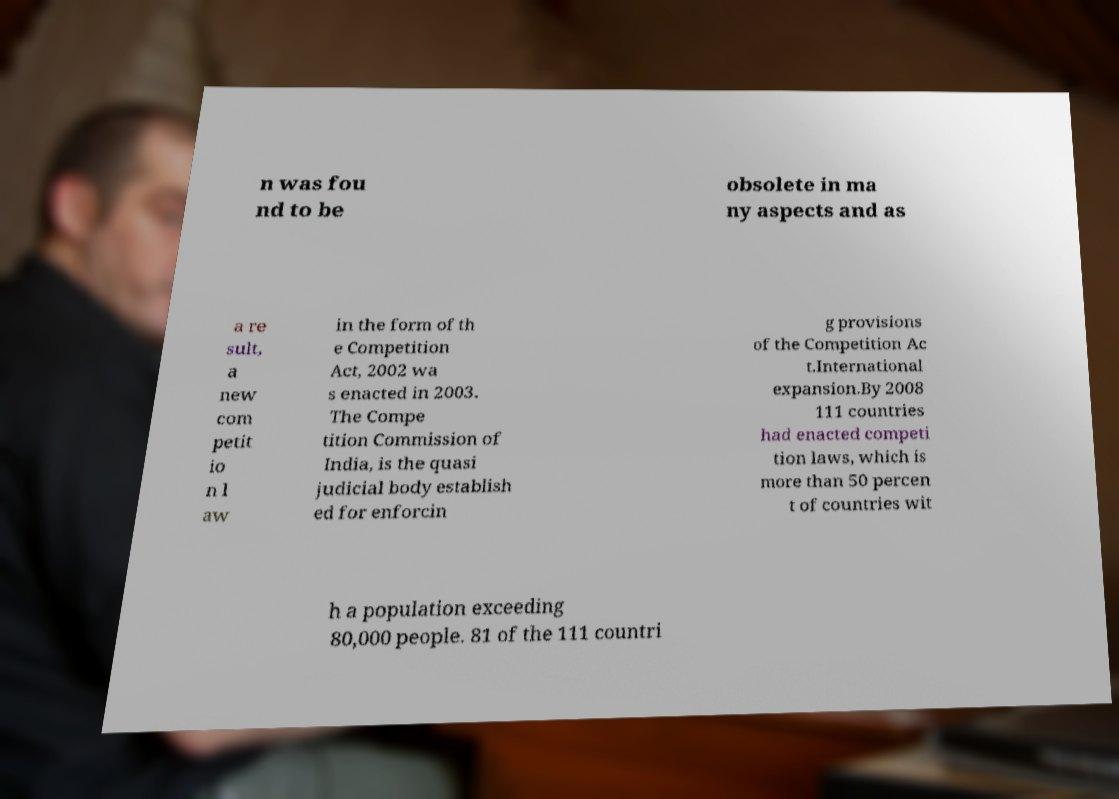There's text embedded in this image that I need extracted. Can you transcribe it verbatim? n was fou nd to be obsolete in ma ny aspects and as a re sult, a new com petit io n l aw in the form of th e Competition Act, 2002 wa s enacted in 2003. The Compe tition Commission of India, is the quasi judicial body establish ed for enforcin g provisions of the Competition Ac t.International expansion.By 2008 111 countries had enacted competi tion laws, which is more than 50 percen t of countries wit h a population exceeding 80,000 people. 81 of the 111 countri 